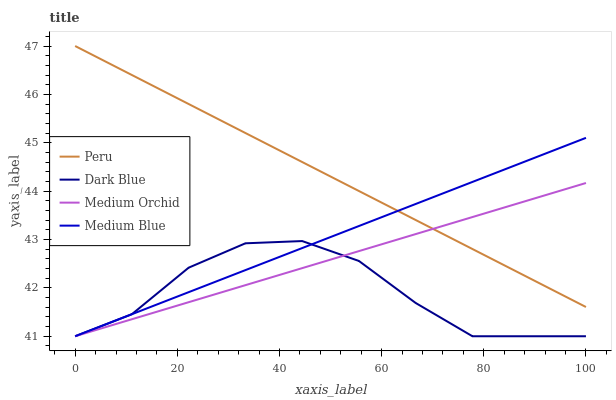Does Dark Blue have the minimum area under the curve?
Answer yes or no. Yes. Does Peru have the maximum area under the curve?
Answer yes or no. Yes. Does Medium Orchid have the minimum area under the curve?
Answer yes or no. No. Does Medium Orchid have the maximum area under the curve?
Answer yes or no. No. Is Peru the smoothest?
Answer yes or no. Yes. Is Dark Blue the roughest?
Answer yes or no. Yes. Is Medium Orchid the smoothest?
Answer yes or no. No. Is Medium Orchid the roughest?
Answer yes or no. No. Does Dark Blue have the lowest value?
Answer yes or no. Yes. Does Peru have the lowest value?
Answer yes or no. No. Does Peru have the highest value?
Answer yes or no. Yes. Does Medium Orchid have the highest value?
Answer yes or no. No. Is Dark Blue less than Peru?
Answer yes or no. Yes. Is Peru greater than Dark Blue?
Answer yes or no. Yes. Does Medium Orchid intersect Dark Blue?
Answer yes or no. Yes. Is Medium Orchid less than Dark Blue?
Answer yes or no. No. Is Medium Orchid greater than Dark Blue?
Answer yes or no. No. Does Dark Blue intersect Peru?
Answer yes or no. No. 